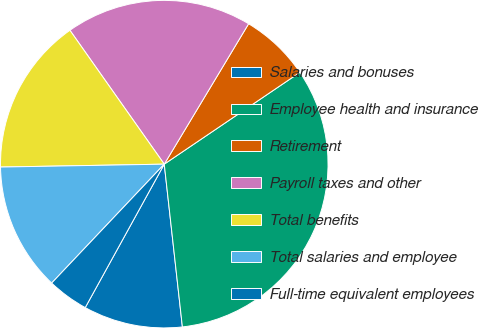Convert chart to OTSL. <chart><loc_0><loc_0><loc_500><loc_500><pie_chart><fcel>Salaries and bonuses<fcel>Employee health and insurance<fcel>Retirement<fcel>Payroll taxes and other<fcel>Total benefits<fcel>Total salaries and employee<fcel>Full-time equivalent employees<nl><fcel>9.78%<fcel>32.7%<fcel>6.92%<fcel>18.38%<fcel>15.51%<fcel>12.65%<fcel>4.05%<nl></chart> 